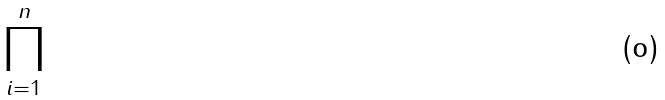<formula> <loc_0><loc_0><loc_500><loc_500>\prod _ { i = 1 } ^ { n }</formula> 